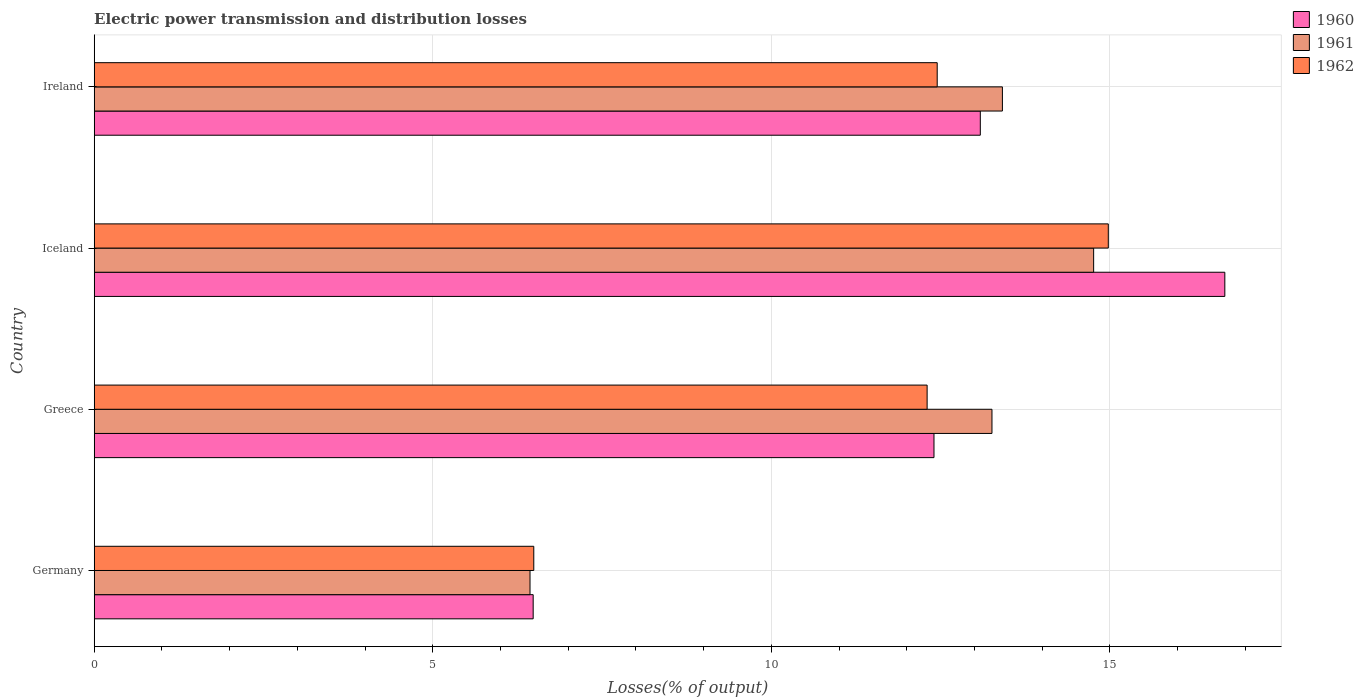How many groups of bars are there?
Ensure brevity in your answer.  4. Are the number of bars per tick equal to the number of legend labels?
Provide a short and direct response. Yes. How many bars are there on the 4th tick from the top?
Give a very brief answer. 3. What is the label of the 3rd group of bars from the top?
Keep it short and to the point. Greece. In how many cases, is the number of bars for a given country not equal to the number of legend labels?
Offer a very short reply. 0. What is the electric power transmission and distribution losses in 1961 in Germany?
Your answer should be very brief. 6.44. Across all countries, what is the maximum electric power transmission and distribution losses in 1961?
Your answer should be compact. 14.76. Across all countries, what is the minimum electric power transmission and distribution losses in 1961?
Offer a very short reply. 6.44. In which country was the electric power transmission and distribution losses in 1960 minimum?
Ensure brevity in your answer.  Germany. What is the total electric power transmission and distribution losses in 1960 in the graph?
Your answer should be very brief. 48.67. What is the difference between the electric power transmission and distribution losses in 1962 in Germany and that in Iceland?
Provide a short and direct response. -8.48. What is the difference between the electric power transmission and distribution losses in 1962 in Ireland and the electric power transmission and distribution losses in 1960 in Iceland?
Make the answer very short. -4.25. What is the average electric power transmission and distribution losses in 1960 per country?
Your answer should be very brief. 12.17. What is the difference between the electric power transmission and distribution losses in 1962 and electric power transmission and distribution losses in 1961 in Iceland?
Your answer should be compact. 0.22. What is the ratio of the electric power transmission and distribution losses in 1961 in Greece to that in Iceland?
Your answer should be very brief. 0.9. Is the electric power transmission and distribution losses in 1962 in Germany less than that in Ireland?
Provide a succinct answer. Yes. What is the difference between the highest and the second highest electric power transmission and distribution losses in 1962?
Your answer should be compact. 2.53. What is the difference between the highest and the lowest electric power transmission and distribution losses in 1961?
Keep it short and to the point. 8.32. In how many countries, is the electric power transmission and distribution losses in 1962 greater than the average electric power transmission and distribution losses in 1962 taken over all countries?
Keep it short and to the point. 3. What does the 3rd bar from the top in Iceland represents?
Ensure brevity in your answer.  1960. How many bars are there?
Offer a terse response. 12. Are all the bars in the graph horizontal?
Your answer should be very brief. Yes. What is the title of the graph?
Offer a very short reply. Electric power transmission and distribution losses. What is the label or title of the X-axis?
Offer a very short reply. Losses(% of output). What is the Losses(% of output) in 1960 in Germany?
Give a very brief answer. 6.48. What is the Losses(% of output) of 1961 in Germany?
Offer a terse response. 6.44. What is the Losses(% of output) of 1962 in Germany?
Offer a very short reply. 6.49. What is the Losses(% of output) of 1960 in Greece?
Your answer should be compact. 12.4. What is the Losses(% of output) in 1961 in Greece?
Offer a terse response. 13.26. What is the Losses(% of output) of 1962 in Greece?
Offer a terse response. 12.3. What is the Losses(% of output) in 1960 in Iceland?
Your answer should be very brief. 16.7. What is the Losses(% of output) in 1961 in Iceland?
Keep it short and to the point. 14.76. What is the Losses(% of output) in 1962 in Iceland?
Your answer should be compact. 14.98. What is the Losses(% of output) in 1960 in Ireland?
Your answer should be very brief. 13.09. What is the Losses(% of output) in 1961 in Ireland?
Keep it short and to the point. 13.41. What is the Losses(% of output) of 1962 in Ireland?
Your answer should be compact. 12.45. Across all countries, what is the maximum Losses(% of output) in 1960?
Ensure brevity in your answer.  16.7. Across all countries, what is the maximum Losses(% of output) in 1961?
Make the answer very short. 14.76. Across all countries, what is the maximum Losses(% of output) of 1962?
Ensure brevity in your answer.  14.98. Across all countries, what is the minimum Losses(% of output) in 1960?
Ensure brevity in your answer.  6.48. Across all countries, what is the minimum Losses(% of output) of 1961?
Keep it short and to the point. 6.44. Across all countries, what is the minimum Losses(% of output) of 1962?
Offer a terse response. 6.49. What is the total Losses(% of output) of 1960 in the graph?
Provide a succinct answer. 48.67. What is the total Losses(% of output) in 1961 in the graph?
Your response must be concise. 47.87. What is the total Losses(% of output) of 1962 in the graph?
Ensure brevity in your answer.  46.22. What is the difference between the Losses(% of output) in 1960 in Germany and that in Greece?
Provide a short and direct response. -5.92. What is the difference between the Losses(% of output) of 1961 in Germany and that in Greece?
Offer a terse response. -6.82. What is the difference between the Losses(% of output) of 1962 in Germany and that in Greece?
Give a very brief answer. -5.81. What is the difference between the Losses(% of output) in 1960 in Germany and that in Iceland?
Make the answer very short. -10.21. What is the difference between the Losses(% of output) in 1961 in Germany and that in Iceland?
Provide a short and direct response. -8.32. What is the difference between the Losses(% of output) in 1962 in Germany and that in Iceland?
Make the answer very short. -8.48. What is the difference between the Losses(% of output) in 1960 in Germany and that in Ireland?
Your answer should be compact. -6.6. What is the difference between the Losses(% of output) in 1961 in Germany and that in Ireland?
Give a very brief answer. -6.98. What is the difference between the Losses(% of output) in 1962 in Germany and that in Ireland?
Offer a very short reply. -5.96. What is the difference between the Losses(% of output) of 1960 in Greece and that in Iceland?
Your response must be concise. -4.3. What is the difference between the Losses(% of output) of 1961 in Greece and that in Iceland?
Provide a succinct answer. -1.5. What is the difference between the Losses(% of output) of 1962 in Greece and that in Iceland?
Provide a short and direct response. -2.68. What is the difference between the Losses(% of output) of 1960 in Greece and that in Ireland?
Offer a very short reply. -0.68. What is the difference between the Losses(% of output) of 1961 in Greece and that in Ireland?
Make the answer very short. -0.15. What is the difference between the Losses(% of output) of 1962 in Greece and that in Ireland?
Provide a succinct answer. -0.15. What is the difference between the Losses(% of output) in 1960 in Iceland and that in Ireland?
Make the answer very short. 3.61. What is the difference between the Losses(% of output) of 1961 in Iceland and that in Ireland?
Provide a short and direct response. 1.35. What is the difference between the Losses(% of output) of 1962 in Iceland and that in Ireland?
Offer a terse response. 2.53. What is the difference between the Losses(% of output) in 1960 in Germany and the Losses(% of output) in 1961 in Greece?
Your response must be concise. -6.78. What is the difference between the Losses(% of output) of 1960 in Germany and the Losses(% of output) of 1962 in Greece?
Offer a terse response. -5.82. What is the difference between the Losses(% of output) in 1961 in Germany and the Losses(% of output) in 1962 in Greece?
Offer a terse response. -5.86. What is the difference between the Losses(% of output) of 1960 in Germany and the Losses(% of output) of 1961 in Iceland?
Provide a short and direct response. -8.28. What is the difference between the Losses(% of output) in 1960 in Germany and the Losses(% of output) in 1962 in Iceland?
Offer a terse response. -8.49. What is the difference between the Losses(% of output) of 1961 in Germany and the Losses(% of output) of 1962 in Iceland?
Your answer should be compact. -8.54. What is the difference between the Losses(% of output) of 1960 in Germany and the Losses(% of output) of 1961 in Ireland?
Provide a succinct answer. -6.93. What is the difference between the Losses(% of output) of 1960 in Germany and the Losses(% of output) of 1962 in Ireland?
Ensure brevity in your answer.  -5.97. What is the difference between the Losses(% of output) of 1961 in Germany and the Losses(% of output) of 1962 in Ireland?
Ensure brevity in your answer.  -6.01. What is the difference between the Losses(% of output) of 1960 in Greece and the Losses(% of output) of 1961 in Iceland?
Make the answer very short. -2.36. What is the difference between the Losses(% of output) of 1960 in Greece and the Losses(% of output) of 1962 in Iceland?
Make the answer very short. -2.57. What is the difference between the Losses(% of output) in 1961 in Greece and the Losses(% of output) in 1962 in Iceland?
Your response must be concise. -1.72. What is the difference between the Losses(% of output) of 1960 in Greece and the Losses(% of output) of 1961 in Ireland?
Keep it short and to the point. -1.01. What is the difference between the Losses(% of output) in 1960 in Greece and the Losses(% of output) in 1962 in Ireland?
Make the answer very short. -0.05. What is the difference between the Losses(% of output) in 1961 in Greece and the Losses(% of output) in 1962 in Ireland?
Offer a terse response. 0.81. What is the difference between the Losses(% of output) of 1960 in Iceland and the Losses(% of output) of 1961 in Ireland?
Provide a succinct answer. 3.28. What is the difference between the Losses(% of output) of 1960 in Iceland and the Losses(% of output) of 1962 in Ireland?
Your answer should be compact. 4.25. What is the difference between the Losses(% of output) in 1961 in Iceland and the Losses(% of output) in 1962 in Ireland?
Keep it short and to the point. 2.31. What is the average Losses(% of output) of 1960 per country?
Make the answer very short. 12.17. What is the average Losses(% of output) in 1961 per country?
Your answer should be very brief. 11.97. What is the average Losses(% of output) of 1962 per country?
Provide a succinct answer. 11.55. What is the difference between the Losses(% of output) in 1960 and Losses(% of output) in 1961 in Germany?
Offer a terse response. 0.05. What is the difference between the Losses(% of output) in 1960 and Losses(% of output) in 1962 in Germany?
Your answer should be compact. -0.01. What is the difference between the Losses(% of output) in 1961 and Losses(% of output) in 1962 in Germany?
Give a very brief answer. -0.06. What is the difference between the Losses(% of output) in 1960 and Losses(% of output) in 1961 in Greece?
Your answer should be compact. -0.86. What is the difference between the Losses(% of output) of 1960 and Losses(% of output) of 1962 in Greece?
Keep it short and to the point. 0.1. What is the difference between the Losses(% of output) of 1961 and Losses(% of output) of 1962 in Greece?
Make the answer very short. 0.96. What is the difference between the Losses(% of output) of 1960 and Losses(% of output) of 1961 in Iceland?
Keep it short and to the point. 1.94. What is the difference between the Losses(% of output) of 1960 and Losses(% of output) of 1962 in Iceland?
Make the answer very short. 1.72. What is the difference between the Losses(% of output) in 1961 and Losses(% of output) in 1962 in Iceland?
Offer a very short reply. -0.22. What is the difference between the Losses(% of output) of 1960 and Losses(% of output) of 1961 in Ireland?
Provide a short and direct response. -0.33. What is the difference between the Losses(% of output) in 1960 and Losses(% of output) in 1962 in Ireland?
Keep it short and to the point. 0.64. What is the difference between the Losses(% of output) in 1961 and Losses(% of output) in 1962 in Ireland?
Offer a very short reply. 0.96. What is the ratio of the Losses(% of output) in 1960 in Germany to that in Greece?
Your response must be concise. 0.52. What is the ratio of the Losses(% of output) of 1961 in Germany to that in Greece?
Offer a very short reply. 0.49. What is the ratio of the Losses(% of output) of 1962 in Germany to that in Greece?
Keep it short and to the point. 0.53. What is the ratio of the Losses(% of output) in 1960 in Germany to that in Iceland?
Make the answer very short. 0.39. What is the ratio of the Losses(% of output) in 1961 in Germany to that in Iceland?
Ensure brevity in your answer.  0.44. What is the ratio of the Losses(% of output) of 1962 in Germany to that in Iceland?
Keep it short and to the point. 0.43. What is the ratio of the Losses(% of output) of 1960 in Germany to that in Ireland?
Provide a short and direct response. 0.5. What is the ratio of the Losses(% of output) in 1961 in Germany to that in Ireland?
Offer a very short reply. 0.48. What is the ratio of the Losses(% of output) in 1962 in Germany to that in Ireland?
Your answer should be very brief. 0.52. What is the ratio of the Losses(% of output) of 1960 in Greece to that in Iceland?
Keep it short and to the point. 0.74. What is the ratio of the Losses(% of output) of 1961 in Greece to that in Iceland?
Provide a succinct answer. 0.9. What is the ratio of the Losses(% of output) in 1962 in Greece to that in Iceland?
Provide a succinct answer. 0.82. What is the ratio of the Losses(% of output) in 1960 in Greece to that in Ireland?
Offer a terse response. 0.95. What is the ratio of the Losses(% of output) in 1961 in Greece to that in Ireland?
Your answer should be compact. 0.99. What is the ratio of the Losses(% of output) of 1960 in Iceland to that in Ireland?
Offer a terse response. 1.28. What is the ratio of the Losses(% of output) in 1961 in Iceland to that in Ireland?
Offer a very short reply. 1.1. What is the ratio of the Losses(% of output) of 1962 in Iceland to that in Ireland?
Ensure brevity in your answer.  1.2. What is the difference between the highest and the second highest Losses(% of output) of 1960?
Your answer should be very brief. 3.61. What is the difference between the highest and the second highest Losses(% of output) in 1961?
Your answer should be compact. 1.35. What is the difference between the highest and the second highest Losses(% of output) in 1962?
Give a very brief answer. 2.53. What is the difference between the highest and the lowest Losses(% of output) of 1960?
Make the answer very short. 10.21. What is the difference between the highest and the lowest Losses(% of output) in 1961?
Provide a succinct answer. 8.32. What is the difference between the highest and the lowest Losses(% of output) in 1962?
Make the answer very short. 8.48. 